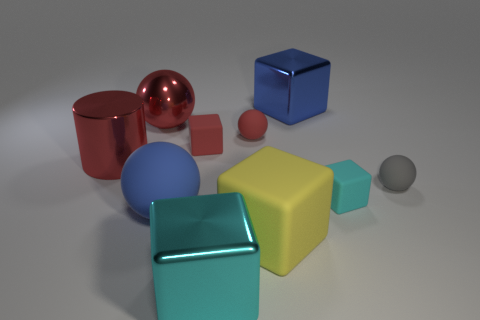Subtract all blue metal blocks. How many blocks are left? 4 Subtract all yellow blocks. How many blocks are left? 4 Subtract 1 blocks. How many blocks are left? 4 Subtract all purple blocks. Subtract all green cylinders. How many blocks are left? 5 Subtract all cylinders. How many objects are left? 9 Subtract all tiny green things. Subtract all big blue metal cubes. How many objects are left? 9 Add 3 tiny red rubber cubes. How many tiny red rubber cubes are left? 4 Add 9 big yellow matte cylinders. How many big yellow matte cylinders exist? 9 Subtract 1 blue spheres. How many objects are left? 9 